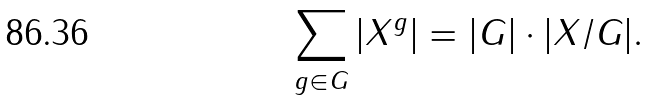<formula> <loc_0><loc_0><loc_500><loc_500>\sum _ { g \in G } | X ^ { g } | = | G | \cdot | X / G | .</formula> 